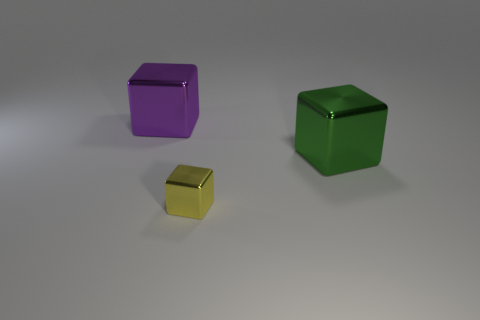Subtract all green metallic cubes. How many cubes are left? 2 Add 1 small yellow metallic blocks. How many objects exist? 4 Add 2 yellow cubes. How many yellow cubes are left? 3 Add 2 big gray metallic things. How many big gray metallic things exist? 2 Subtract 1 green cubes. How many objects are left? 2 Subtract all big cyan cubes. Subtract all big objects. How many objects are left? 1 